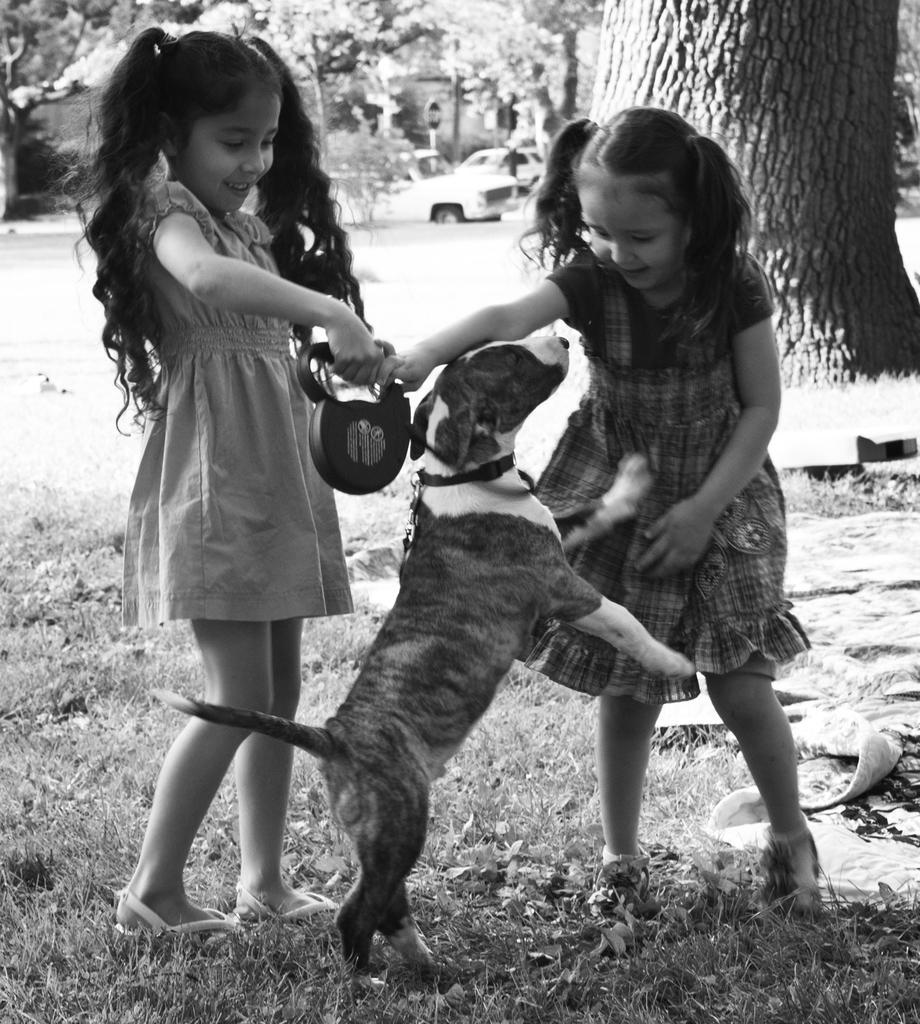In one or two sentences, can you explain what this image depicts? This is a black and white image. There are two girls in this image and dog. Both of them are holding hands and there is a tree on the top right corner. There is grass in the bottom. 